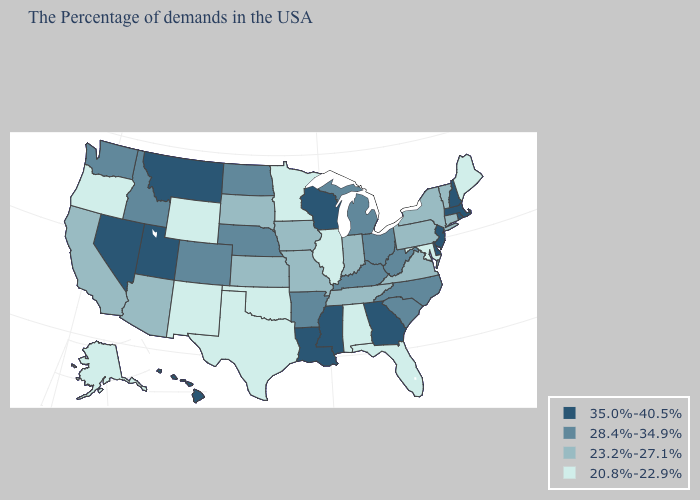Does Wisconsin have the highest value in the MidWest?
Write a very short answer. Yes. What is the value of Alaska?
Give a very brief answer. 20.8%-22.9%. What is the value of Colorado?
Quick response, please. 28.4%-34.9%. Name the states that have a value in the range 20.8%-22.9%?
Quick response, please. Maine, Maryland, Florida, Alabama, Illinois, Minnesota, Oklahoma, Texas, Wyoming, New Mexico, Oregon, Alaska. Name the states that have a value in the range 35.0%-40.5%?
Keep it brief. Massachusetts, Rhode Island, New Hampshire, New Jersey, Delaware, Georgia, Wisconsin, Mississippi, Louisiana, Utah, Montana, Nevada, Hawaii. Does Washington have the same value as Colorado?
Concise answer only. Yes. Is the legend a continuous bar?
Answer briefly. No. Which states hav the highest value in the Northeast?
Be succinct. Massachusetts, Rhode Island, New Hampshire, New Jersey. Name the states that have a value in the range 23.2%-27.1%?
Quick response, please. Vermont, Connecticut, New York, Pennsylvania, Virginia, Indiana, Tennessee, Missouri, Iowa, Kansas, South Dakota, Arizona, California. Which states hav the highest value in the MidWest?
Concise answer only. Wisconsin. Does the first symbol in the legend represent the smallest category?
Short answer required. No. Name the states that have a value in the range 28.4%-34.9%?
Give a very brief answer. North Carolina, South Carolina, West Virginia, Ohio, Michigan, Kentucky, Arkansas, Nebraska, North Dakota, Colorado, Idaho, Washington. Which states have the lowest value in the USA?
Be succinct. Maine, Maryland, Florida, Alabama, Illinois, Minnesota, Oklahoma, Texas, Wyoming, New Mexico, Oregon, Alaska. What is the lowest value in states that border Wyoming?
Be succinct. 23.2%-27.1%. What is the lowest value in the USA?
Give a very brief answer. 20.8%-22.9%. 